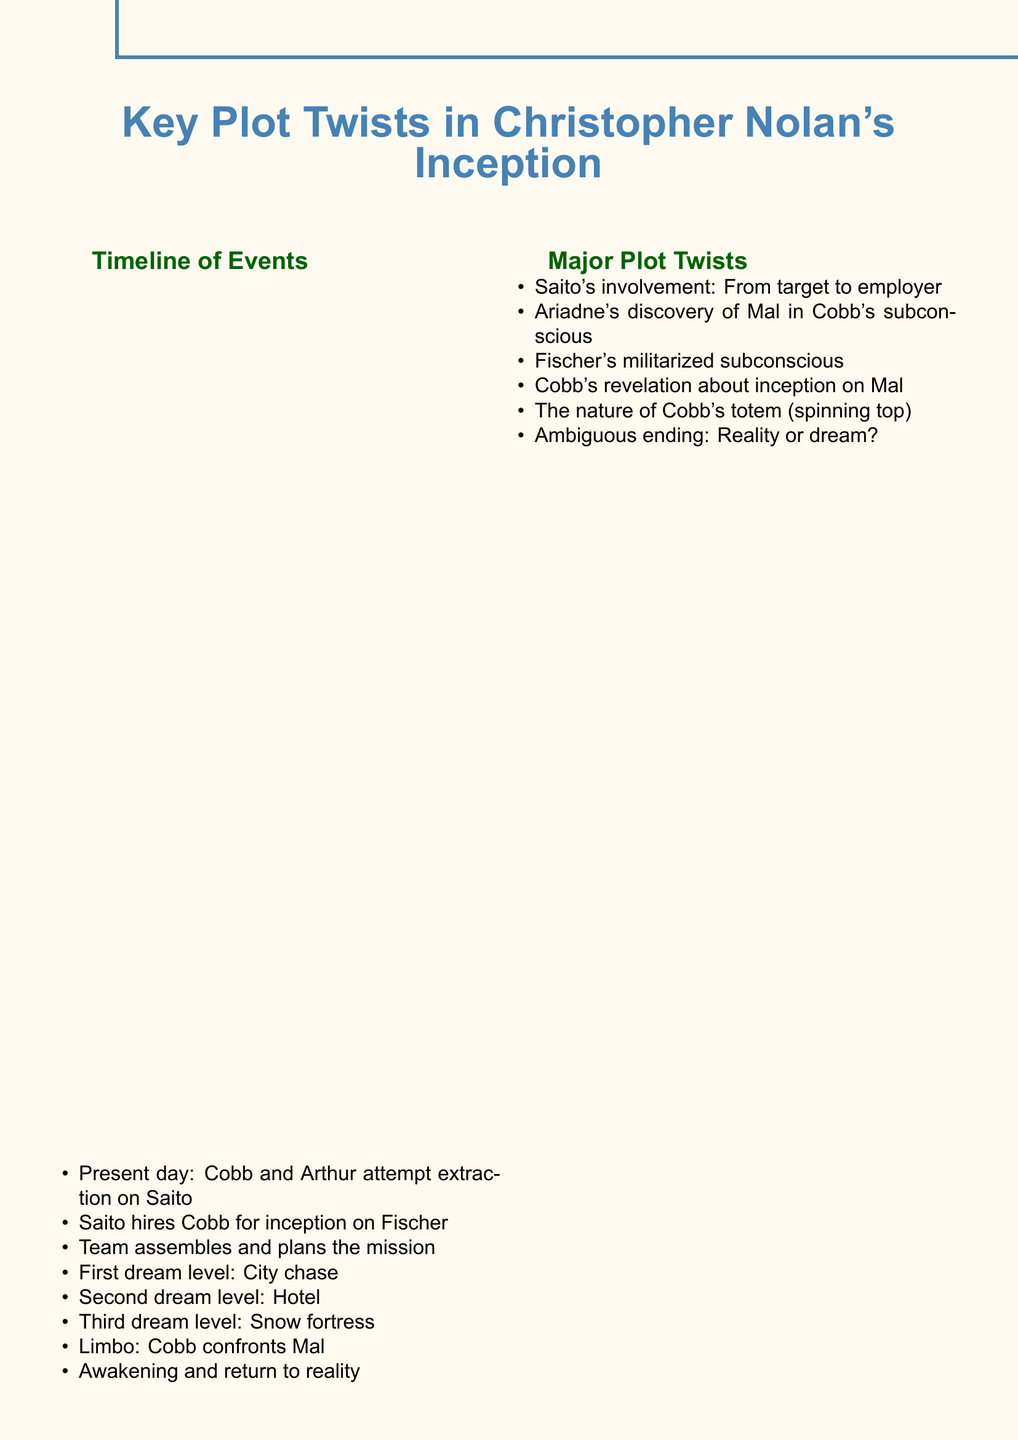What is the first dream level? The first dream level is the setting of the first act of the mission, where the team experiences a city chase.
Answer: City chase Who is Cobb's main motivation in the film? Cobb's main motivation throughout the film is to return home to his children, which drives his actions.
Answer: Children What occurs in Limbo? In Limbo, Cobb confronts Mal, which is a key emotional moment showcasing his struggle with his subconscious.
Answer: Cobb confronts Mal What is the nature of Cobb's totem? The nature of Cobb's totem, which serves as a reality indicator for him, is a spinning top central to the film's themes of reality versus illusion.
Answer: Spinning top What does Ariadne discover in Cobb's subconscious? Ariadne discovers Mal within Cobb's subconscious, revealing the emotional baggage he carries.
Answer: Mal How many dream levels are there during the mission? The mission consists of three dream levels, each introducing different challenges and environments.
Answer: Three What is the ambiguous ending about? The ambiguous ending of the film leaves the audience questioning whether Cobb is in reality or still dreaming, which adds to the film's complexity.
Answer: Reality or dream What is Saito's role in the plot? Saito transitions from being a target to becoming Cobb's employer, altering the dynamics of their relationship significantly.
Answer: Employer What motivates Eames in the film? Eames is motivated by his enjoyment of the challenge involved in the inception mission, reflecting his character's playful nature.
Answer: Enjoyment of the challenge 